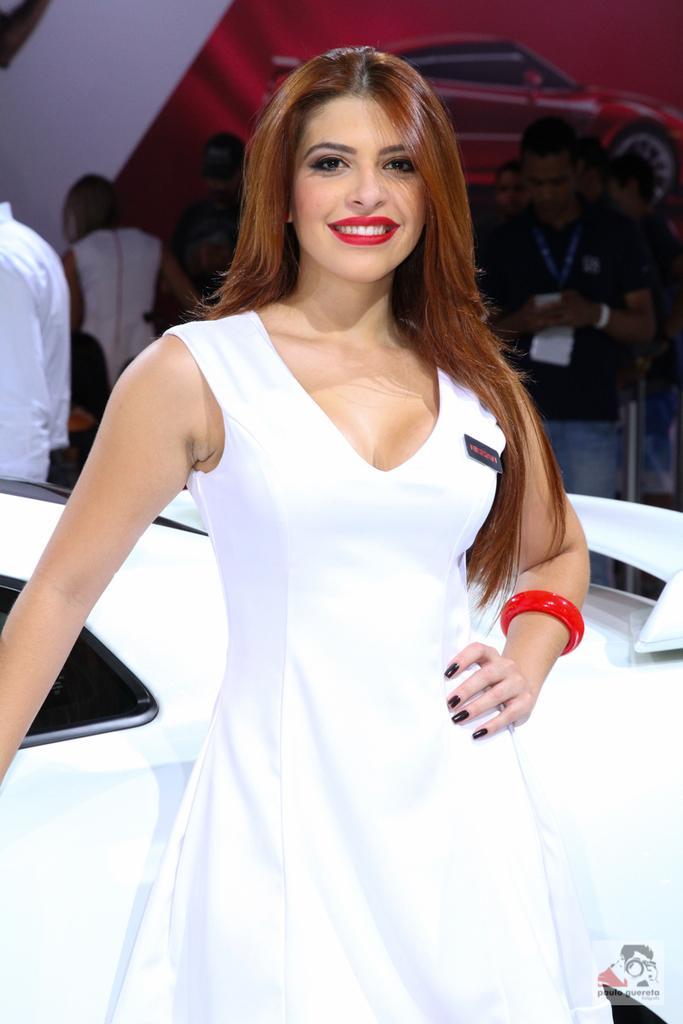In one or two sentences, can you explain what this image depicts? In this image we can see a woman standing beside a car. On the backside we can see a group of people standing and the picture of a car on the surface. 